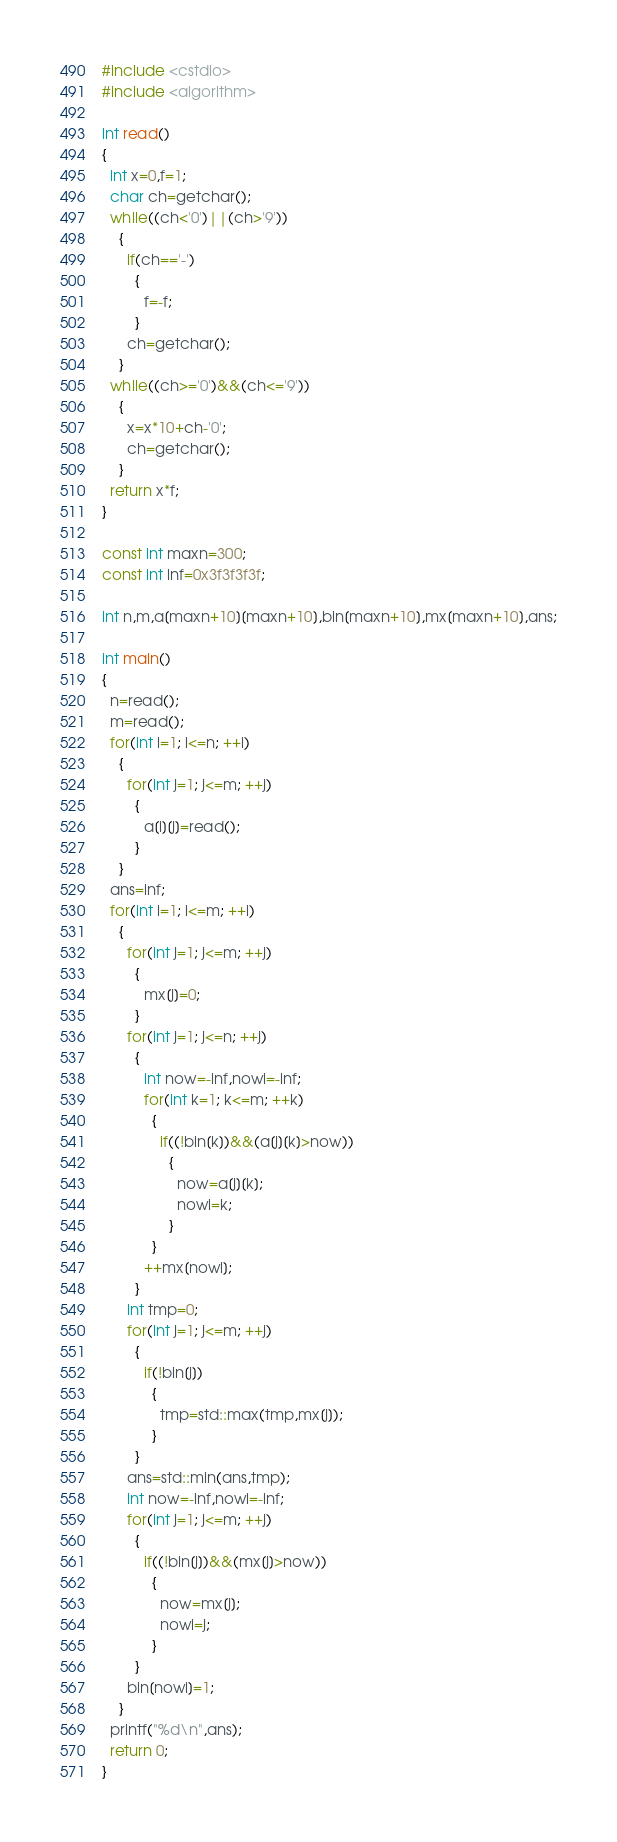Convert code to text. <code><loc_0><loc_0><loc_500><loc_500><_C++_>#include <cstdio>
#include <algorithm>

int read()
{
  int x=0,f=1;
  char ch=getchar();
  while((ch<'0')||(ch>'9'))
    {
      if(ch=='-')
        {
          f=-f;
        }
      ch=getchar();
    }
  while((ch>='0')&&(ch<='9'))
    {
      x=x*10+ch-'0';
      ch=getchar();
    }
  return x*f;
}

const int maxn=300;
const int inf=0x3f3f3f3f;

int n,m,a[maxn+10][maxn+10],bin[maxn+10],mx[maxn+10],ans;

int main()
{
  n=read();
  m=read();
  for(int i=1; i<=n; ++i)
    {
      for(int j=1; j<=m; ++j)
        {
          a[i][j]=read();
        }
    }
  ans=inf;
  for(int i=1; i<=m; ++i)
    {
      for(int j=1; j<=m; ++j)
        {
          mx[j]=0;
        }
      for(int j=1; j<=n; ++j)
        {
          int now=-inf,nowi=-inf;
          for(int k=1; k<=m; ++k)
            {
              if((!bin[k])&&(a[j][k]>now))
                {
                  now=a[j][k];
                  nowi=k;
                }
            }
          ++mx[nowi];
        }
      int tmp=0;
      for(int j=1; j<=m; ++j)
        {
          if(!bin[j])
            {
              tmp=std::max(tmp,mx[j]);
            }
        }
      ans=std::min(ans,tmp);
      int now=-inf,nowi=-inf;
      for(int j=1; j<=m; ++j)
        {
          if((!bin[j])&&(mx[j]>now))
            {
              now=mx[j];
              nowi=j;
            }
        }
      bin[nowi]=1;
    }
  printf("%d\n",ans);
  return 0;
}
</code> 